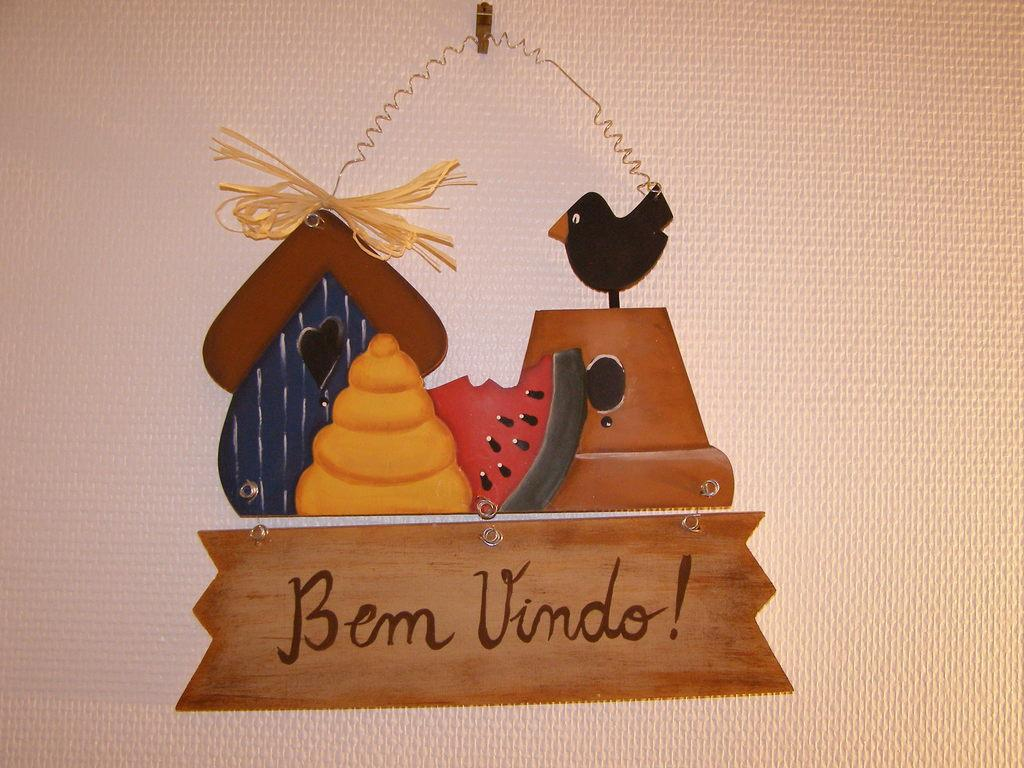What is the primary object in the image? There is a white color tissue paper in the image. What is depicted on the tissue paper? The tissue paper has a painting on it. Can you describe the painting in more detail? The painting consists of some text at the bottom. What type of metal is used to create the shocking elbow in the image? There is no mention of a shocking elbow or any metal in the image; it features a white color tissue paper with a painting that includes text at the bottom. 